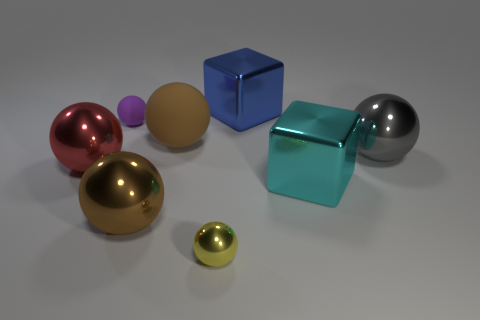Subtract 2 spheres. How many spheres are left? 4 Subtract all brown matte spheres. How many spheres are left? 5 Subtract all red balls. How many balls are left? 5 Subtract all yellow spheres. Subtract all brown cylinders. How many spheres are left? 5 Add 1 tiny rubber things. How many objects exist? 9 Subtract all balls. How many objects are left? 2 Add 6 large gray metallic objects. How many large gray metallic objects are left? 7 Add 8 yellow rubber cylinders. How many yellow rubber cylinders exist? 8 Subtract 0 purple blocks. How many objects are left? 8 Subtract all green rubber spheres. Subtract all small yellow metallic balls. How many objects are left? 7 